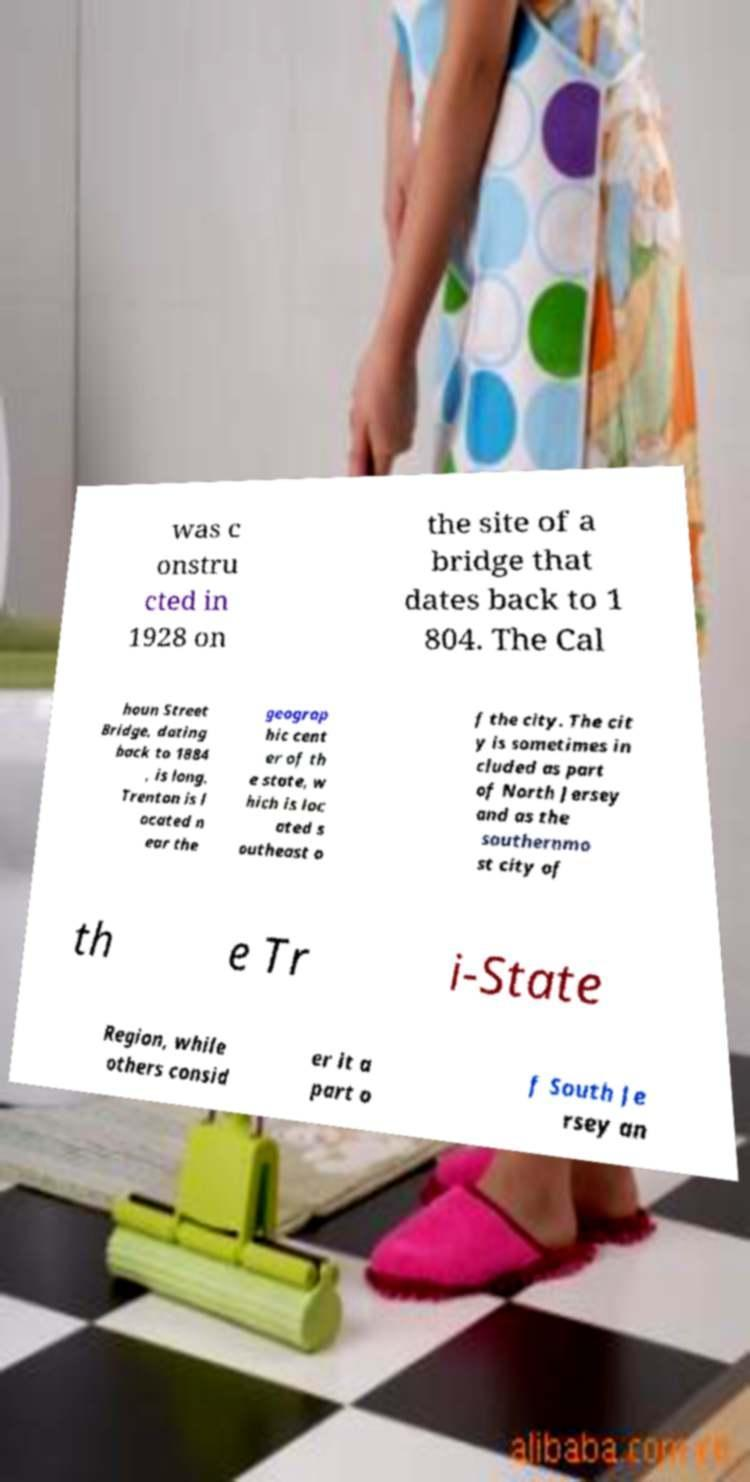For documentation purposes, I need the text within this image transcribed. Could you provide that? was c onstru cted in 1928 on the site of a bridge that dates back to 1 804. The Cal houn Street Bridge, dating back to 1884 , is long. Trenton is l ocated n ear the geograp hic cent er of th e state, w hich is loc ated s outheast o f the city. The cit y is sometimes in cluded as part of North Jersey and as the southernmo st city of th e Tr i-State Region, while others consid er it a part o f South Je rsey an 